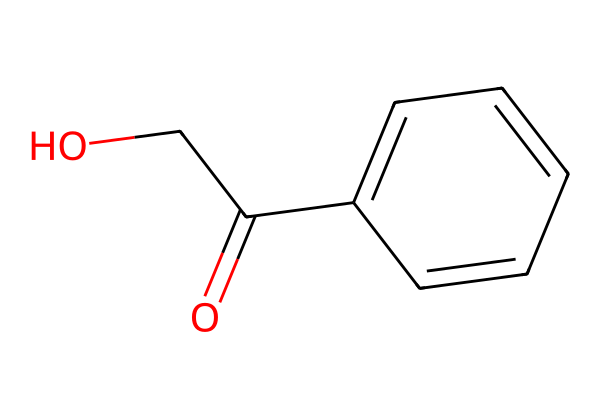What is the number of carbon atoms in this chemical? The SMILES representation shows "c1ccccc1" which indicates a benzene ring, containing six carbon atoms, and "OCC(=O)" includes two additional carbon atoms. Adding them together gives a total of eight carbon atoms.
Answer: eight What type of functional group is present in this chemical? The presence of "C(=O)" indicates a carbonyl group, specifically an ester functional group from "OCC(=O)". Therefore, this chemical includes an ester functional group.
Answer: ester How many hydrogen atoms are in this compound? The benzene ring contributes five hydrogen atoms (since one carbon is bound to another group), and the two carbons in the tail provide four hydrogen atoms total from "OCC". Adding these gives a total of nine hydrogen atoms.
Answer: nine What characteristic of this chemical makes it a suitable film developer? The presence of the benzene ring structure contributes to its stability and chemical reactivity, making it suitable for developing photographic film.
Answer: stability What is the molecular weight of this compound? Considering that the individual weights of carbon (12.01 g/mol), hydrogen (1.008 g/mol), and oxygen (16.00 g/mol) are multiplied by their respective atom counts, we can calculate the molecular weight: (8*12.01)+(9*1.008)+(2*16.00). This totals approximately 150.16 g/mol.
Answer: approximately 150.16 g/mol What is the oxidation state of the oxygen atoms in this compound? In this compound, the oxygen in the carbonyl group is in the oxidation state of -2, and the oxygen in the -O- bond is generally considered -2 as well, thus both are -2.
Answer: -2 